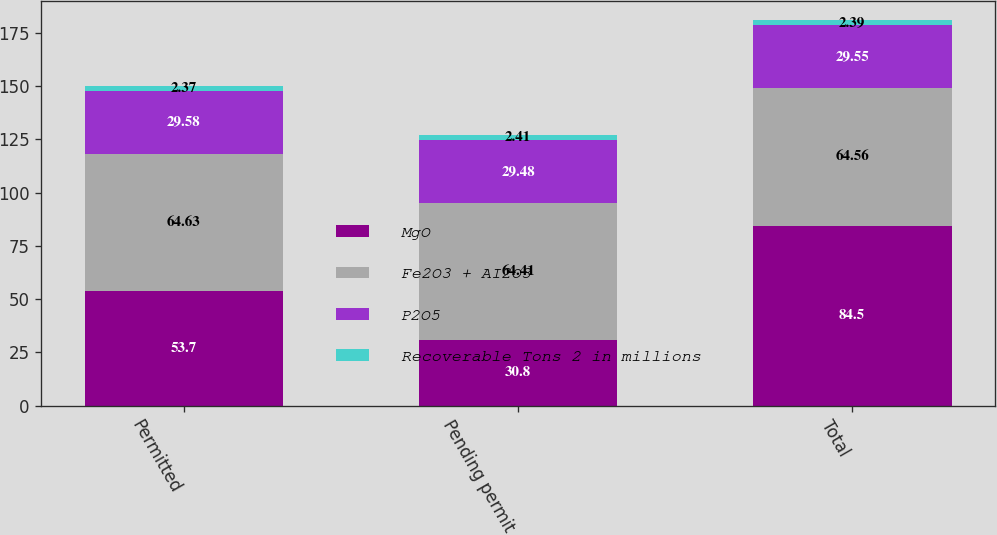Convert chart. <chart><loc_0><loc_0><loc_500><loc_500><stacked_bar_chart><ecel><fcel>Permitted<fcel>Pending permit<fcel>Total<nl><fcel>MgO<fcel>53.7<fcel>30.8<fcel>84.5<nl><fcel>Fe2O3 + AI2O3<fcel>64.63<fcel>64.41<fcel>64.56<nl><fcel>P2O5<fcel>29.58<fcel>29.48<fcel>29.55<nl><fcel>Recoverable Tons 2 in millions<fcel>2.37<fcel>2.41<fcel>2.39<nl></chart> 